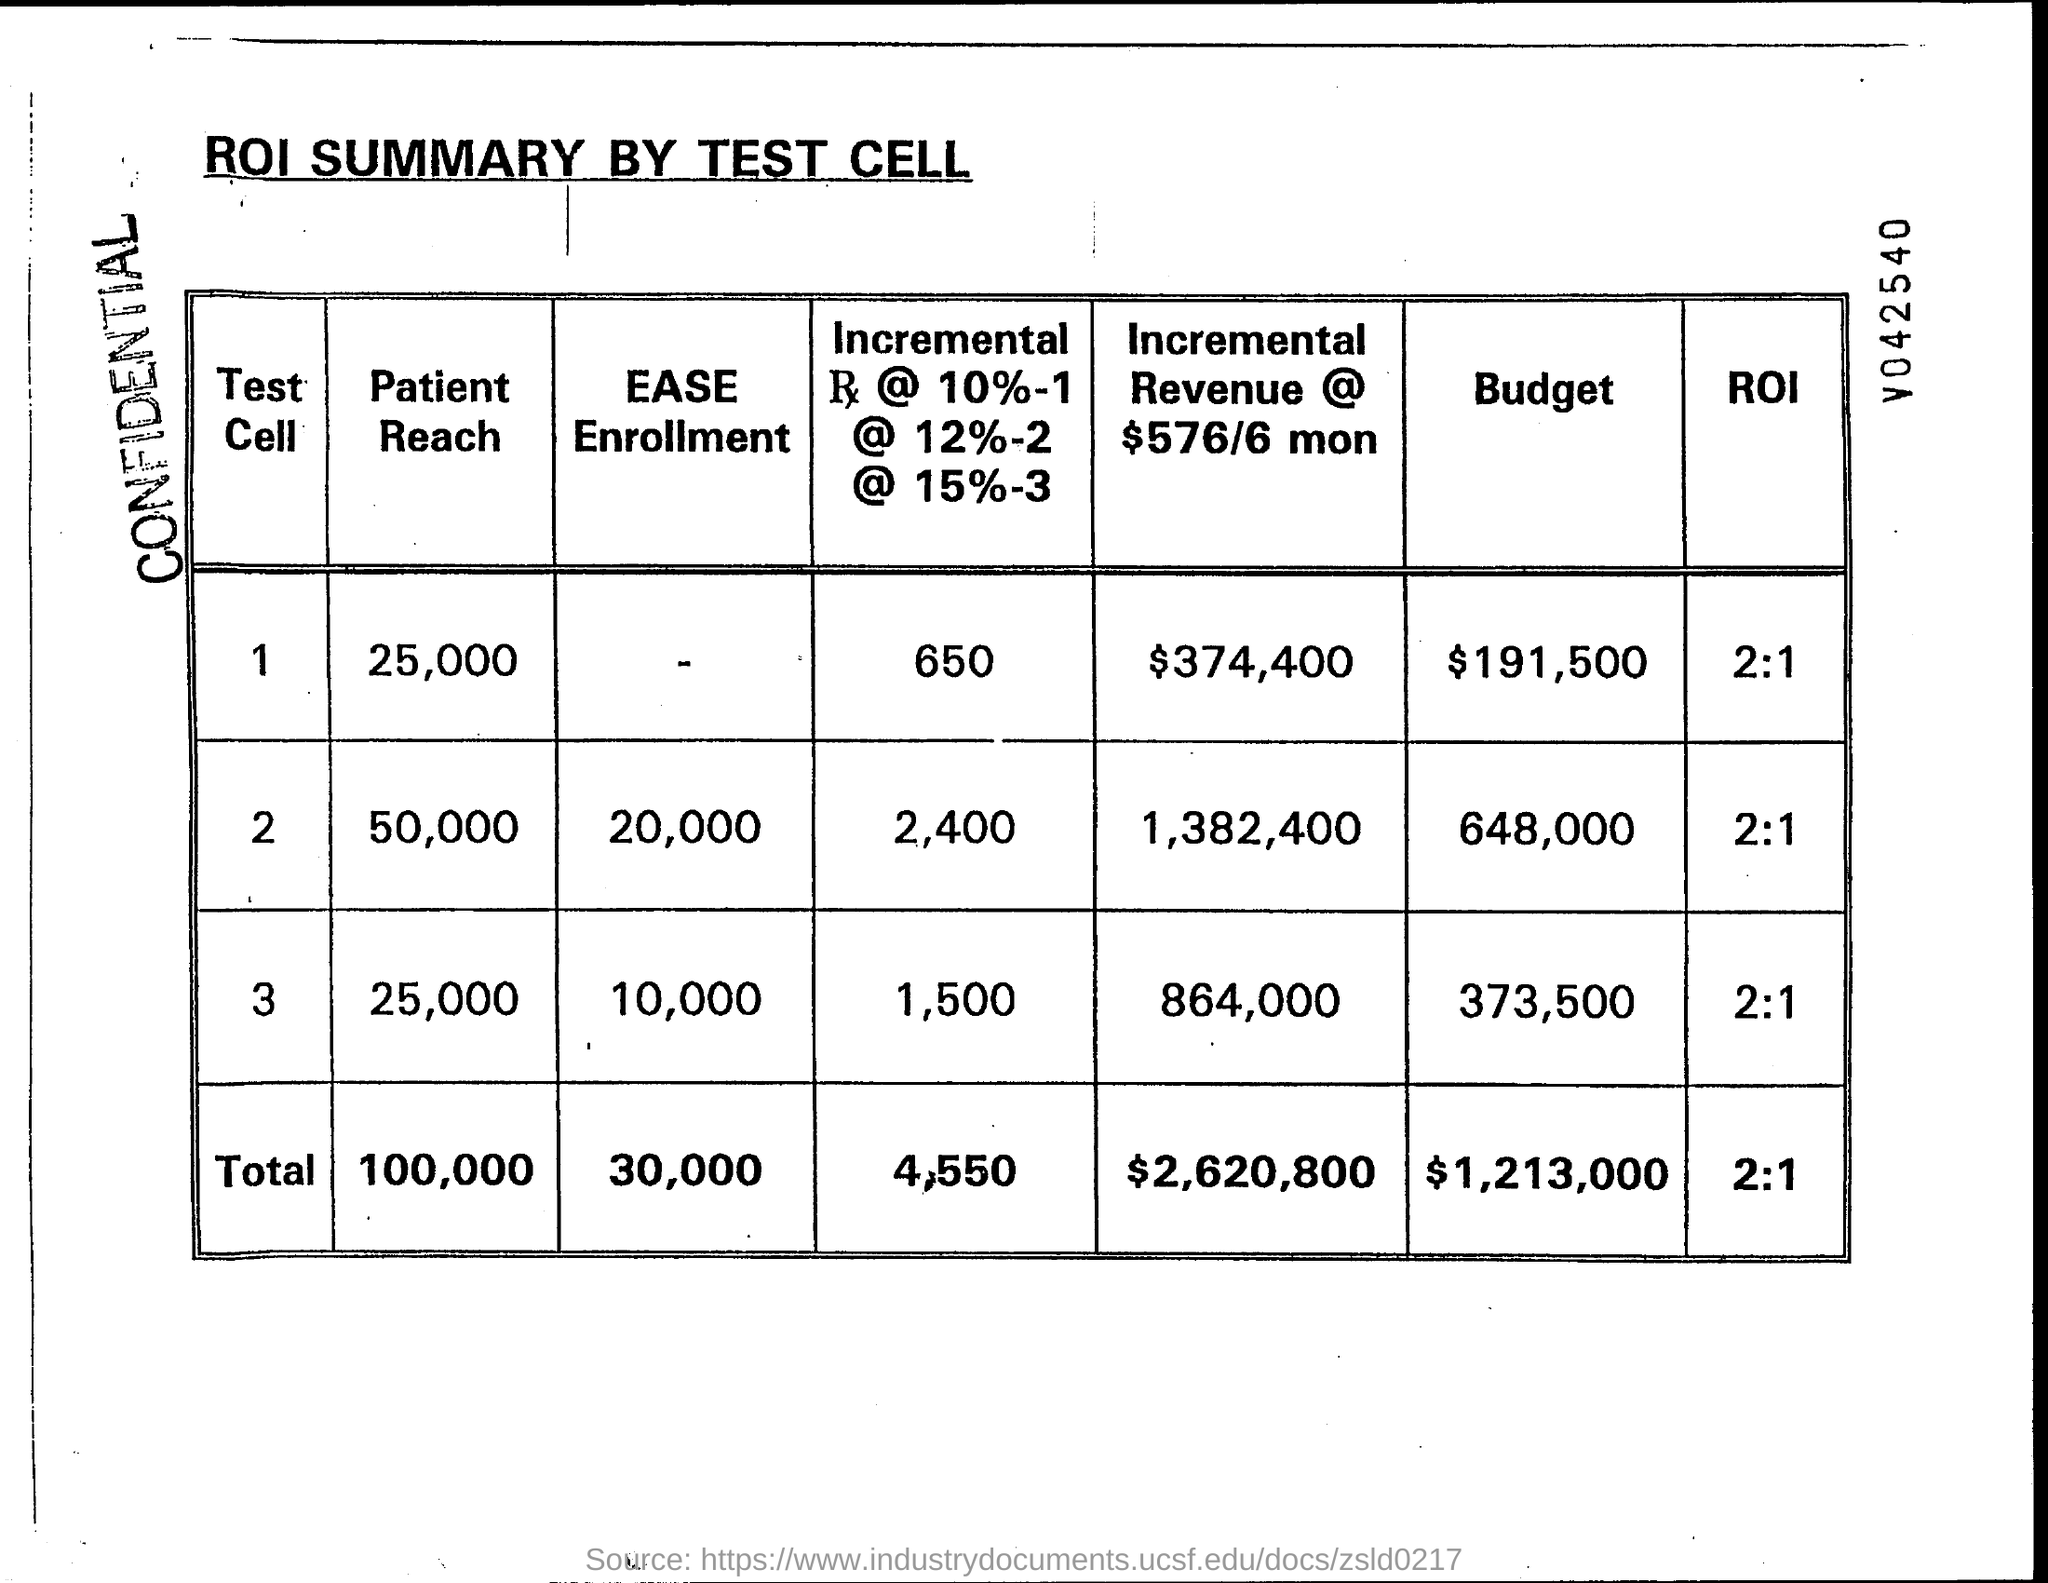What is the total budget ?
Your response must be concise. $1,213,000. What is the total patient reach ?
Provide a short and direct response. 100,000. What is the total ease enrollment ?
Provide a short and direct response. 30,000. What is the total roi?
Ensure brevity in your answer.  2:1. What is the total incremental revenue @ $ 576/6 mon ?
Ensure brevity in your answer.  $2,620,800. 